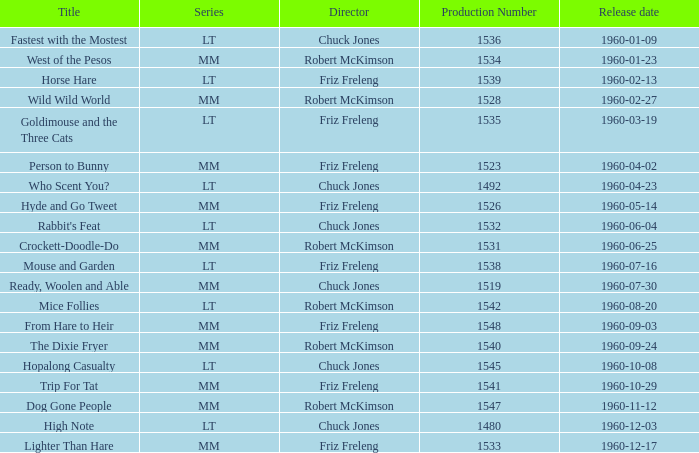What is the production number for the episode directed by Robert McKimson named Mice Follies? 1.0. 